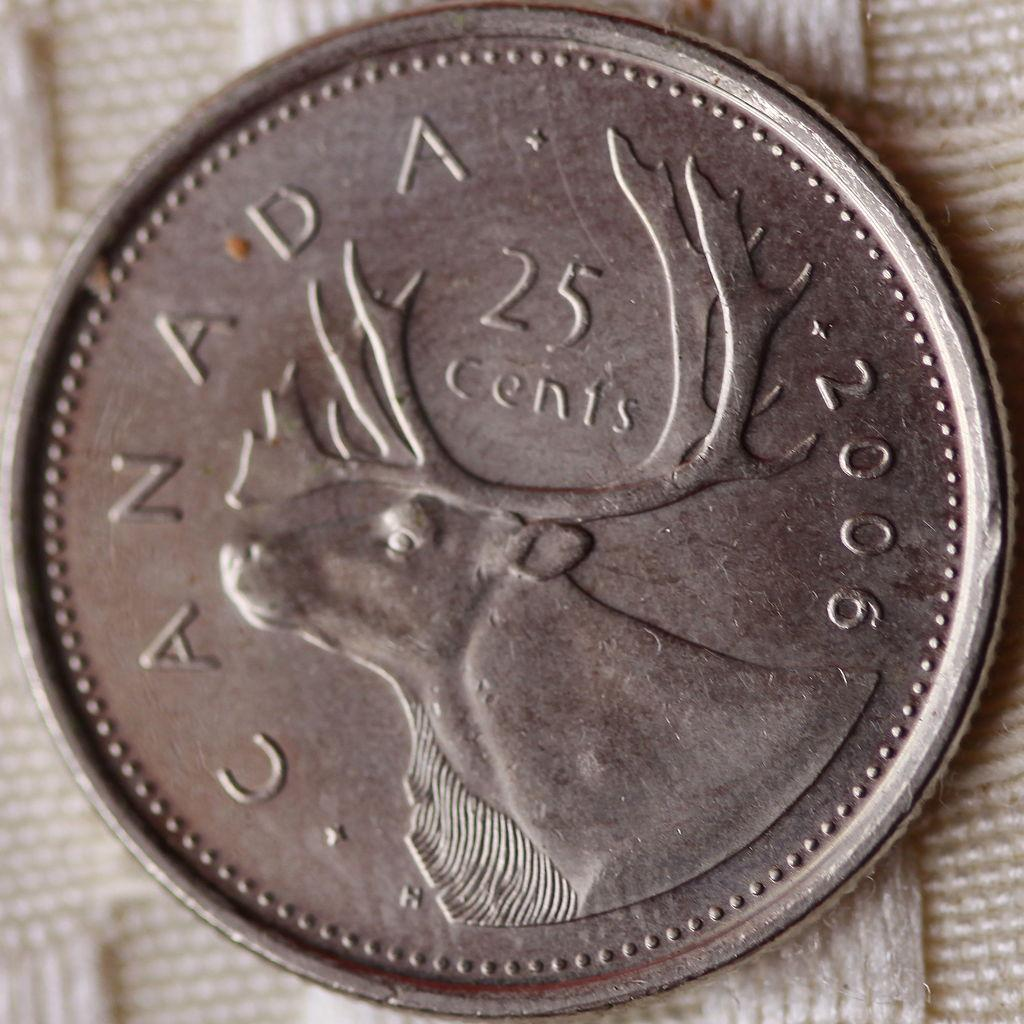What is the main object in the image? There is a coin in the image. What is the coin placed on? The coin is placed on a white cloth. What can be seen on the surface of the coin? There is text and numbers on the coin. What type of image is present on the coin? There is an animal image on the coin. What does your sister remember about the bird she saw last week? There is no mention of a sister or a bird in the image, so we cannot answer this question based on the provided facts. 